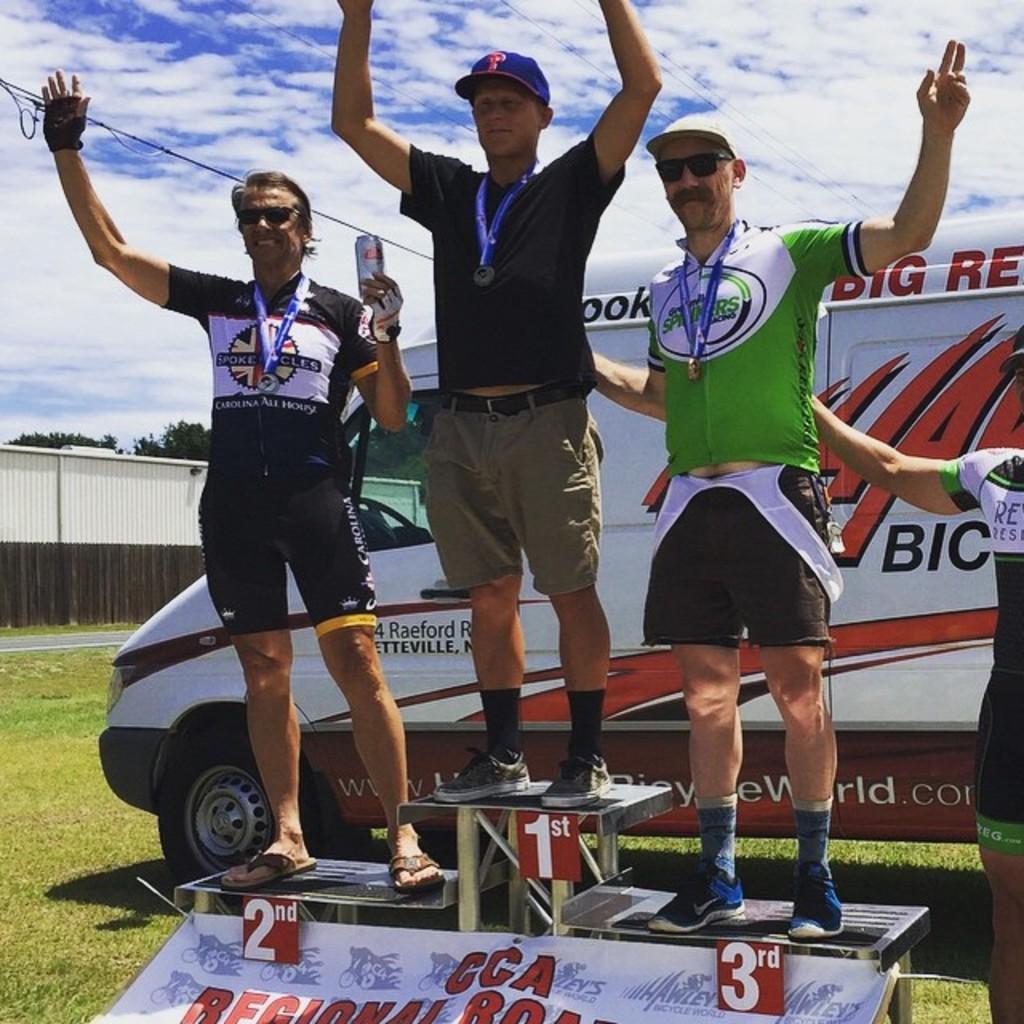Can you describe this image briefly? There are three men standing and smiling. They wear medals, T-shirts and shoes. This looks like a banner. These are the cards with numbers. On the right side of the image, I can see another person standing. This looks like a wall. I think these are the trees. These are the clouds in the sky. Here is the grass. 